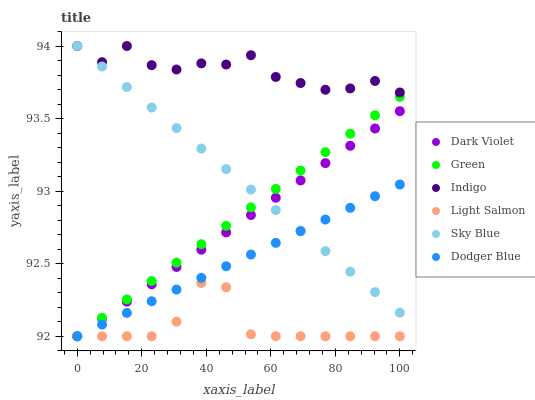Does Light Salmon have the minimum area under the curve?
Answer yes or no. Yes. Does Indigo have the maximum area under the curve?
Answer yes or no. Yes. Does Dark Violet have the minimum area under the curve?
Answer yes or no. No. Does Dark Violet have the maximum area under the curve?
Answer yes or no. No. Is Dodger Blue the smoothest?
Answer yes or no. Yes. Is Indigo the roughest?
Answer yes or no. Yes. Is Dark Violet the smoothest?
Answer yes or no. No. Is Dark Violet the roughest?
Answer yes or no. No. Does Light Salmon have the lowest value?
Answer yes or no. Yes. Does Indigo have the lowest value?
Answer yes or no. No. Does Sky Blue have the highest value?
Answer yes or no. Yes. Does Dark Violet have the highest value?
Answer yes or no. No. Is Green less than Indigo?
Answer yes or no. Yes. Is Indigo greater than Green?
Answer yes or no. Yes. Does Dark Violet intersect Sky Blue?
Answer yes or no. Yes. Is Dark Violet less than Sky Blue?
Answer yes or no. No. Is Dark Violet greater than Sky Blue?
Answer yes or no. No. Does Green intersect Indigo?
Answer yes or no. No. 